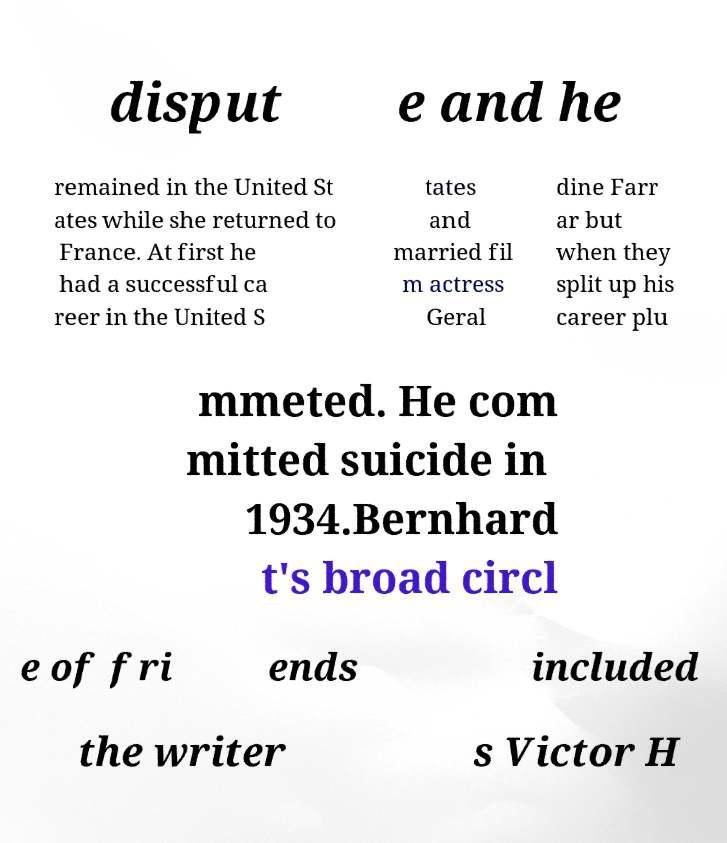Could you extract and type out the text from this image? disput e and he remained in the United St ates while she returned to France. At first he had a successful ca reer in the United S tates and married fil m actress Geral dine Farr ar but when they split up his career plu mmeted. He com mitted suicide in 1934.Bernhard t's broad circl e of fri ends included the writer s Victor H 